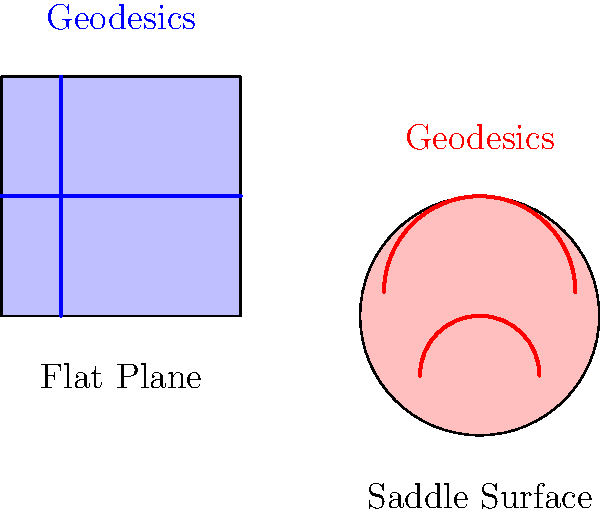In the context of Non-Euclidean Geometry, how do the geodesics (shortest paths) on a flat plane differ from those on a saddle-shaped surface, and how might this concept relate to analyzing financial trends in the film industry? To understand the difference between geodesics on a flat plane and a saddle-shaped surface, let's break it down step-by-step:

1. Flat Plane:
   - On a flat plane, geodesics are straight lines.
   - They follow the principle of Euclidean geometry.
   - The shortest distance between two points is always a straight line.

2. Saddle-shaped Surface:
   - On a saddle-shaped surface, geodesics are curved lines.
   - They follow the principles of Non-Euclidean geometry.
   - The shortest path between two points is not necessarily a straight line, but rather a curve that follows the surface's contours.

3. Key Differences:
   - Direction: Flat plane geodesics maintain a constant direction, while saddle surface geodesics change direction as they follow the surface's curvature.
   - Distance: The distance between two points on a flat plane is easily calculable using the Pythagorean theorem, while on a saddle surface, it requires more complex calculations involving the surface's curvature.

4. Relation to Financial Trends in Film Industry:
   - Linear vs. Non-linear Trends: Flat plane geodesics could represent linear financial trends, while saddle surface geodesics might represent more complex, non-linear trends in the film industry.
   - Risk Assessment: Understanding these geometric concepts can help in visualizing and analyzing risk patterns in film production finances.
   - Budget Projections: Non-linear geodesics could represent how initial budget estimates might need to be adjusted as a project progresses, accounting for unforeseen variables.
   - Market Analysis: The saddle shape could represent the dynamic nature of the film market, where trends don't always follow straight, predictable paths.

5. Practical Application:
   - When analyzing financial data or projecting future trends, an accountant in the film industry should be aware that not all patterns will follow simple, linear paths (flat plane).
   - Some financial trends may require more complex modeling (saddle surface) to accurately represent and predict outcomes.

Understanding these geometric concepts can provide a framework for more sophisticated financial analysis and forecasting in the dynamic film production industry.
Answer: Flat plane geodesics are straight lines, while saddle surface geodesics are curved, representing linear vs. non-linear financial trends in film production. 